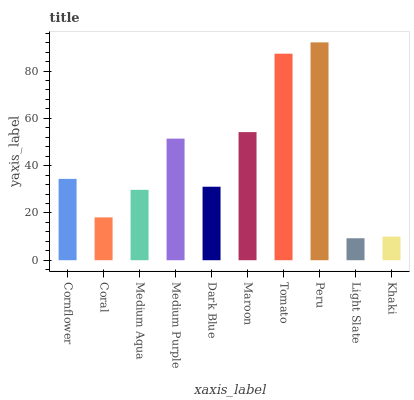Is Light Slate the minimum?
Answer yes or no. Yes. Is Peru the maximum?
Answer yes or no. Yes. Is Coral the minimum?
Answer yes or no. No. Is Coral the maximum?
Answer yes or no. No. Is Cornflower greater than Coral?
Answer yes or no. Yes. Is Coral less than Cornflower?
Answer yes or no. Yes. Is Coral greater than Cornflower?
Answer yes or no. No. Is Cornflower less than Coral?
Answer yes or no. No. Is Cornflower the high median?
Answer yes or no. Yes. Is Dark Blue the low median?
Answer yes or no. Yes. Is Dark Blue the high median?
Answer yes or no. No. Is Peru the low median?
Answer yes or no. No. 